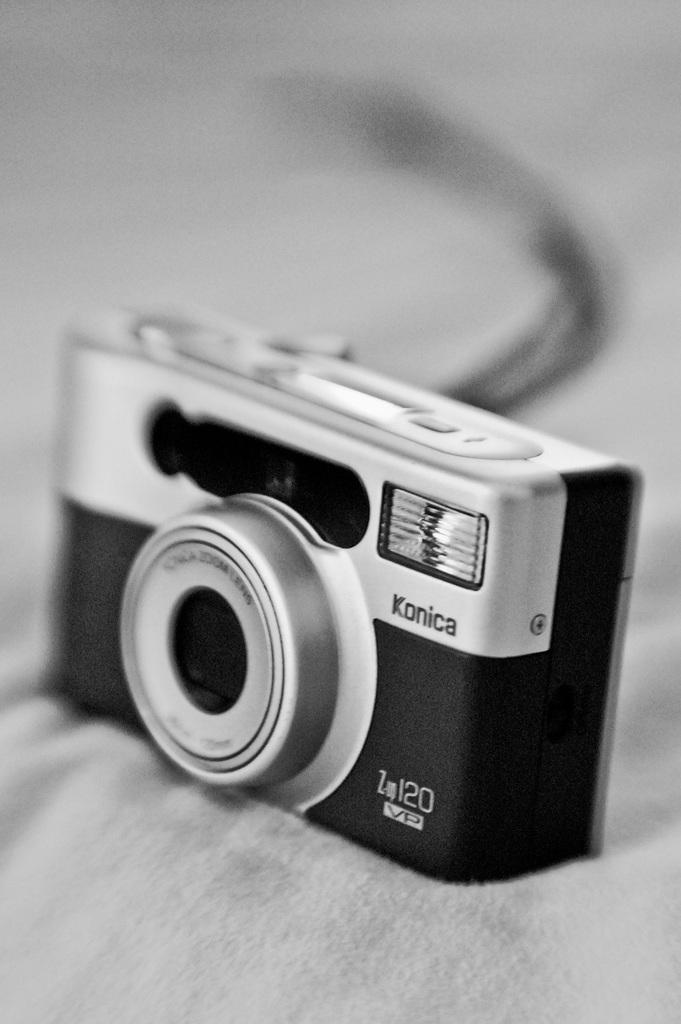What object is the main focus of the image? There is a camera in the image. What can be observed about the background of the image? The background of the image is blurred. How would you describe the color scheme of the image? The image is black and white. What type of substance is being played with in the image? There is no substance being played with in the image; it features a camera with a blurred background and a black and white color scheme. 